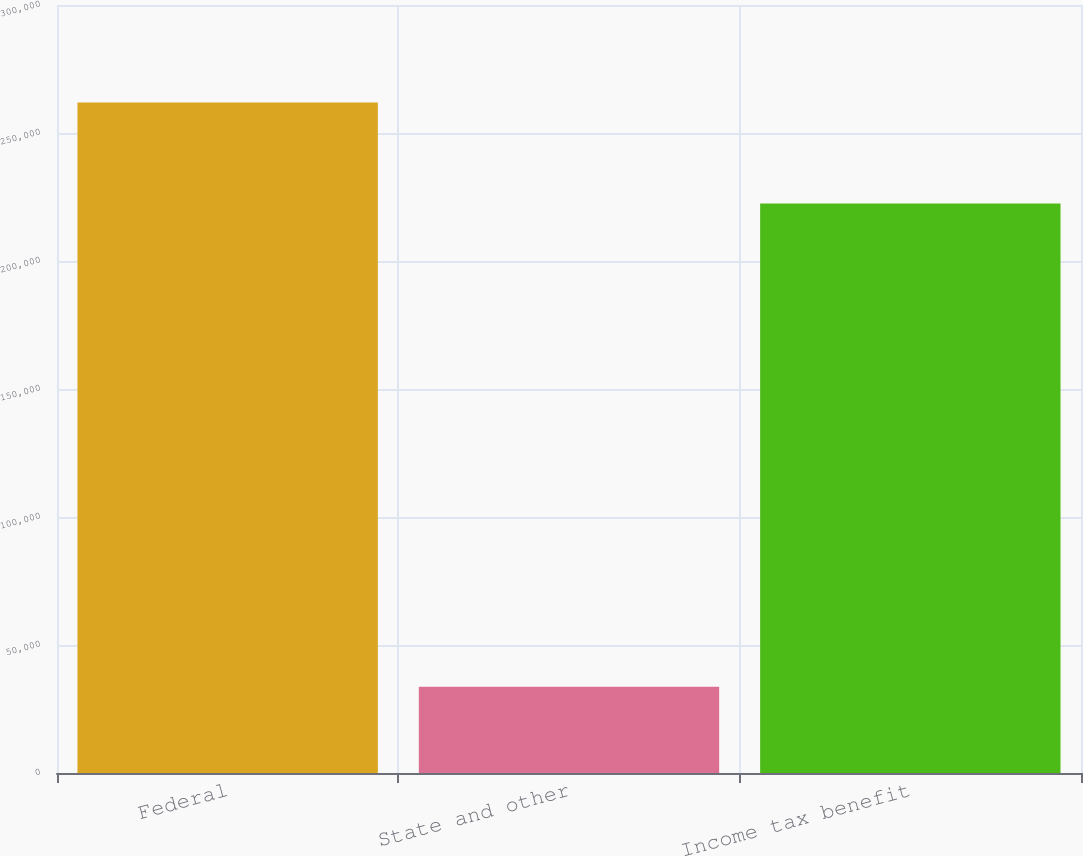<chart> <loc_0><loc_0><loc_500><loc_500><bar_chart><fcel>Federal<fcel>State and other<fcel>Income tax benefit<nl><fcel>261921<fcel>33729<fcel>222486<nl></chart> 